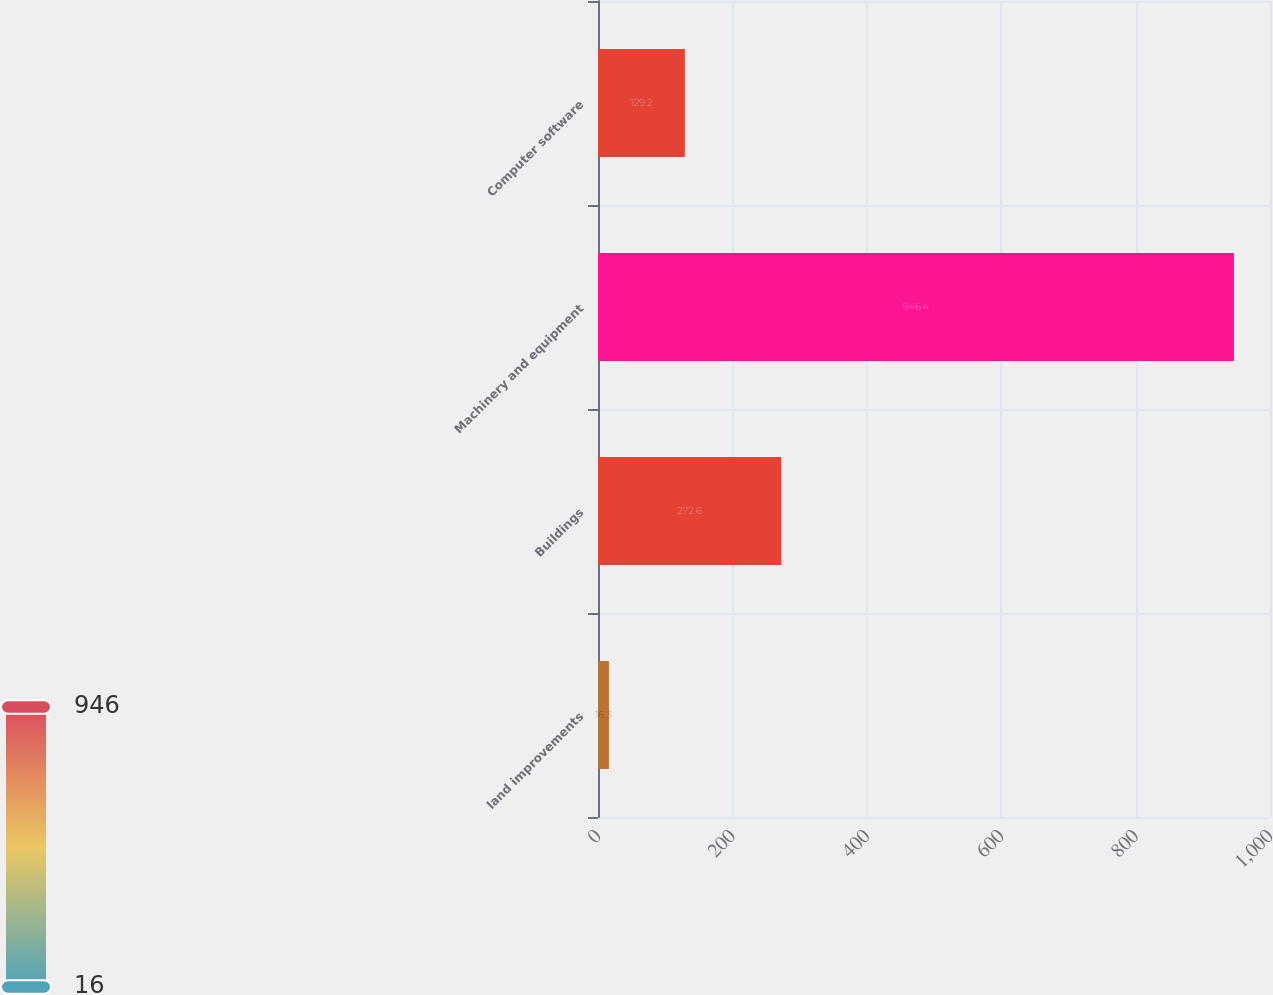Convert chart. <chart><loc_0><loc_0><loc_500><loc_500><bar_chart><fcel>land improvements<fcel>Buildings<fcel>Machinery and equipment<fcel>Computer software<nl><fcel>16.3<fcel>272.6<fcel>946.4<fcel>129.2<nl></chart> 